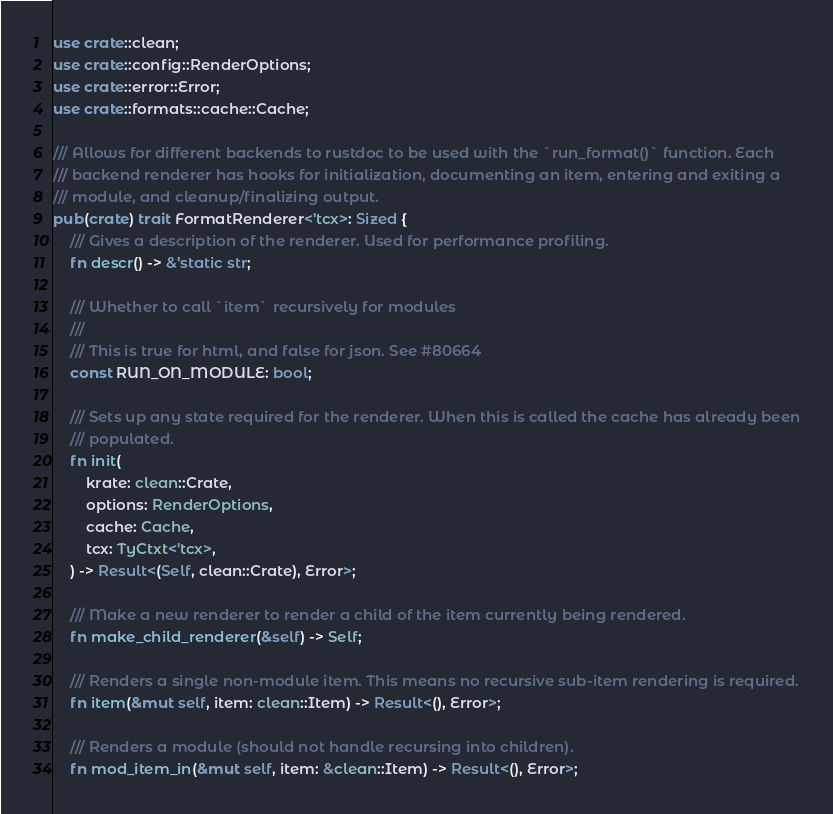Convert code to text. <code><loc_0><loc_0><loc_500><loc_500><_Rust_>use crate::clean;
use crate::config::RenderOptions;
use crate::error::Error;
use crate::formats::cache::Cache;

/// Allows for different backends to rustdoc to be used with the `run_format()` function. Each
/// backend renderer has hooks for initialization, documenting an item, entering and exiting a
/// module, and cleanup/finalizing output.
pub(crate) trait FormatRenderer<'tcx>: Sized {
    /// Gives a description of the renderer. Used for performance profiling.
    fn descr() -> &'static str;

    /// Whether to call `item` recursively for modules
    ///
    /// This is true for html, and false for json. See #80664
    const RUN_ON_MODULE: bool;

    /// Sets up any state required for the renderer. When this is called the cache has already been
    /// populated.
    fn init(
        krate: clean::Crate,
        options: RenderOptions,
        cache: Cache,
        tcx: TyCtxt<'tcx>,
    ) -> Result<(Self, clean::Crate), Error>;

    /// Make a new renderer to render a child of the item currently being rendered.
    fn make_child_renderer(&self) -> Self;

    /// Renders a single non-module item. This means no recursive sub-item rendering is required.
    fn item(&mut self, item: clean::Item) -> Result<(), Error>;

    /// Renders a module (should not handle recursing into children).
    fn mod_item_in(&mut self, item: &clean::Item) -> Result<(), Error>;
</code> 